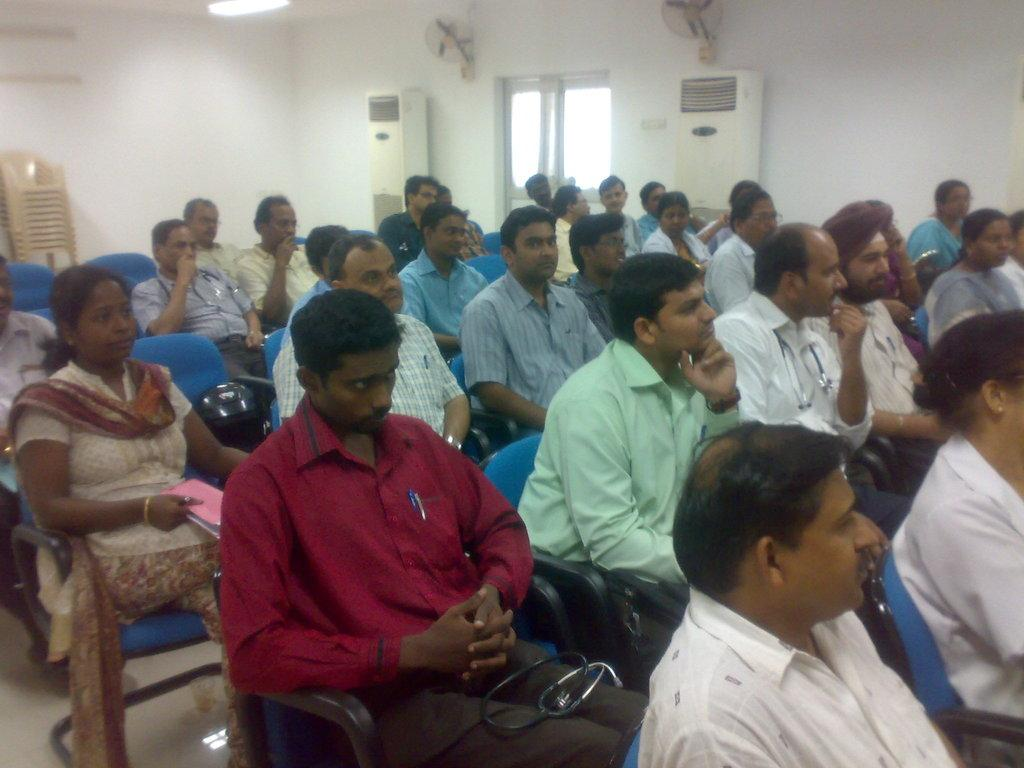What is the main subject of the image? The main subject of the image is a group of people. What are the people in the image doing? The people are sitting on chairs. Can you tell me how many rabbits are sitting on chairs in the image? There are no rabbits present in the image; it features a group of people sitting on chairs. What type of waste is visible in the image? There is no waste visible in the image; it features a group of people sitting on chairs. 